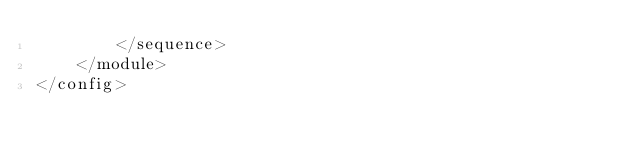<code> <loc_0><loc_0><loc_500><loc_500><_XML_>        </sequence>
    </module>
</config>
</code> 